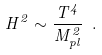Convert formula to latex. <formula><loc_0><loc_0><loc_500><loc_500>H ^ { 2 } \sim \frac { T ^ { 4 } } { M ^ { 2 } _ { p l } } \ .</formula> 